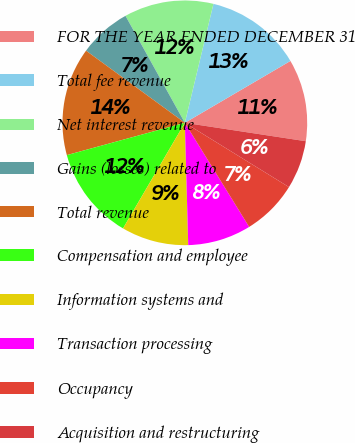Convert chart. <chart><loc_0><loc_0><loc_500><loc_500><pie_chart><fcel>FOR THE YEAR ENDED DECEMBER 31<fcel>Total fee revenue<fcel>Net interest revenue<fcel>Gains (losses) related to<fcel>Total revenue<fcel>Compensation and employee<fcel>Information systems and<fcel>Transaction processing<fcel>Occupancy<fcel>Acquisition and restructuring<nl><fcel>10.84%<fcel>12.81%<fcel>11.82%<fcel>6.9%<fcel>14.29%<fcel>12.32%<fcel>8.87%<fcel>8.37%<fcel>7.39%<fcel>6.4%<nl></chart> 